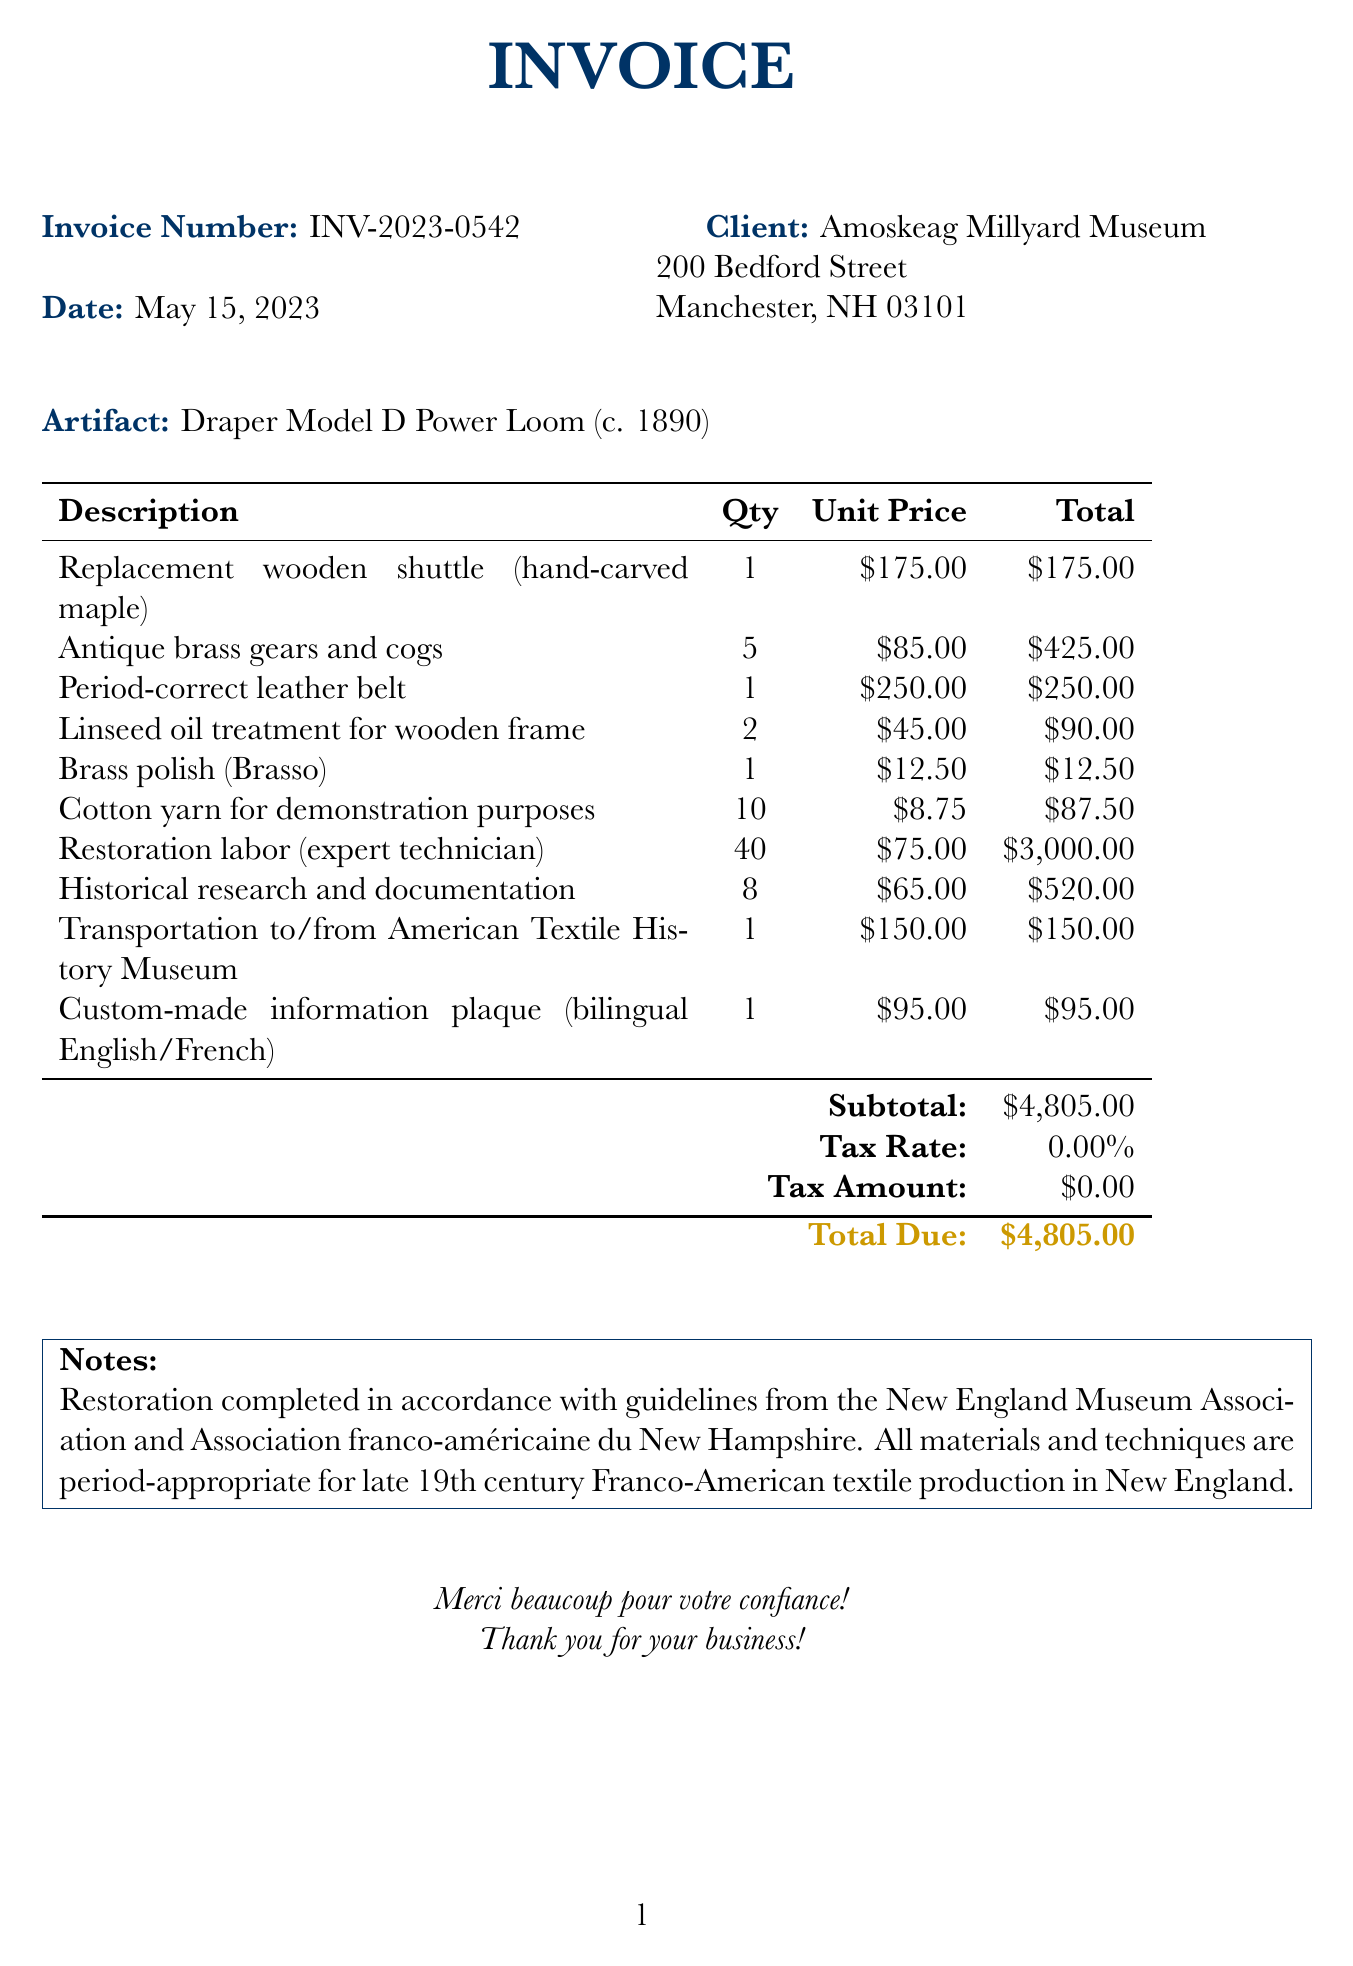What is the invoice number? The invoice number is clearly stated at the top of the document as INV-2023-0542.
Answer: INV-2023-0542 What is the date of the invoice? The date of the invoice is provided directly underneath the invoice number as May 15, 2023.
Answer: May 15, 2023 Who is the client of the invoice? The client's name, Amoskeag Millyard Museum, is mentioned below the date of the invoice.
Answer: Amoskeag Millyard Museum What is the total amount due? The total amount due is summarized at the end of the invoice, showing the total as $4,805.00.
Answer: $4,805.00 How many antique brass gears and cogs are listed in the invoice? The quantity of antique brass gears and cogs can be found in the itemized list under description, which shows a quantity of 5.
Answer: 5 What is the description of the artifact? The description of the artifact is provided as Draper Model D Power Loom (c. 1890) in the document.
Answer: Draper Model D Power Loom (c. 1890) What labor cost is associated with the restoration? The labor cost is detailed in the items list, showing restoration labor with a total of $3,000.00 for 40 hours.
Answer: $3,000.00 Is there any tax included in the invoice? The tax rate is mentioned as 0.00%, indicating that no tax is included in the total.
Answer: 0.00% What language is the custom information plaque presented in? The invoice specifies that the custom-made information plaque is bilingual, indicating both English and French.
Answer: Bilingual English/French 